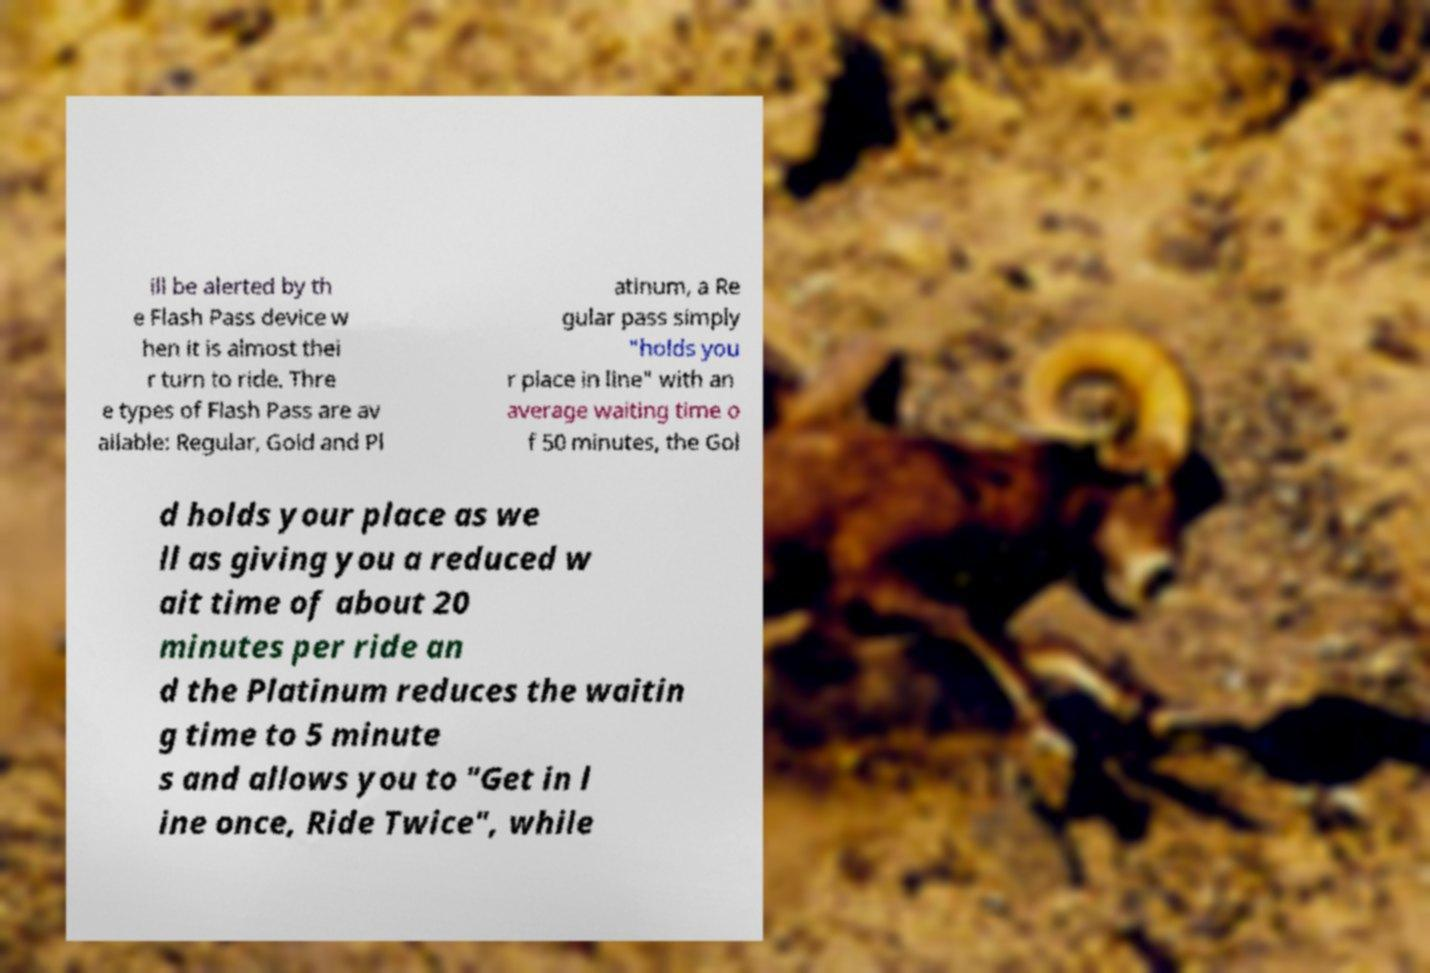Please identify and transcribe the text found in this image. ill be alerted by th e Flash Pass device w hen it is almost thei r turn to ride. Thre e types of Flash Pass are av ailable: Regular, Gold and Pl atinum, a Re gular pass simply "holds you r place in line" with an average waiting time o f 50 minutes, the Gol d holds your place as we ll as giving you a reduced w ait time of about 20 minutes per ride an d the Platinum reduces the waitin g time to 5 minute s and allows you to "Get in l ine once, Ride Twice", while 